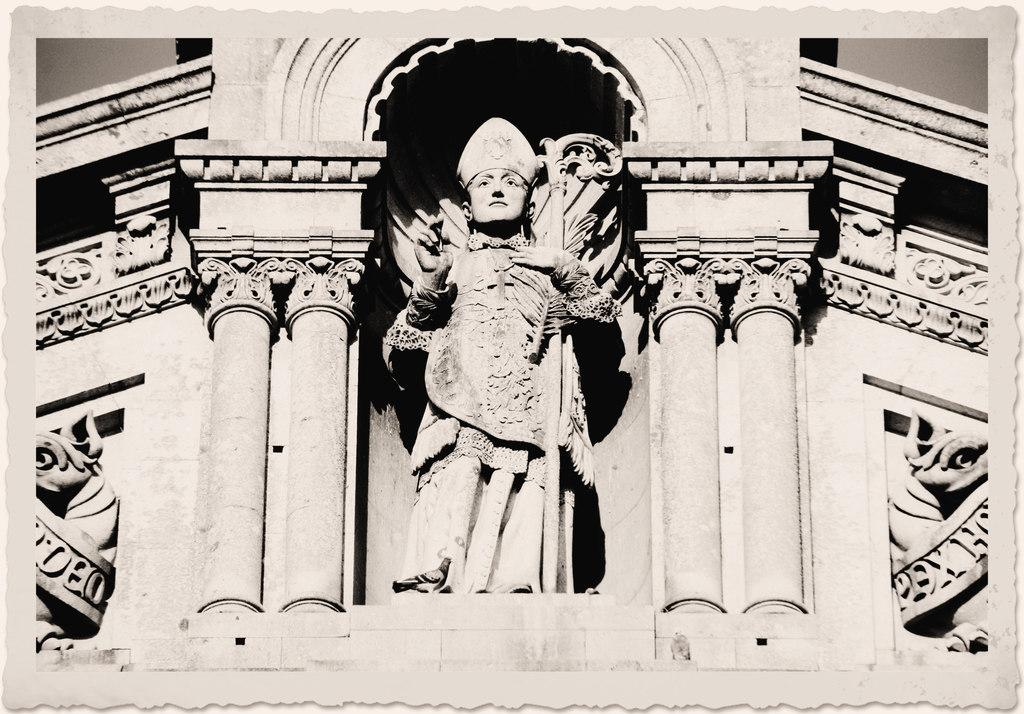What is the main subject of the image? There is a sculpture in the image. Where is the sculpture located in relation to other objects or structures? The sculpture is near a building. What type of bread is being used to create the sculpture in the image? There is no bread present in the image; the sculpture is not made of bread. What appliance is being used to shape the sculpture in the image? There is no appliance visible in the image that is being used to shape the sculpture. 